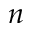Convert formula to latex. <formula><loc_0><loc_0><loc_500><loc_500>n</formula> 